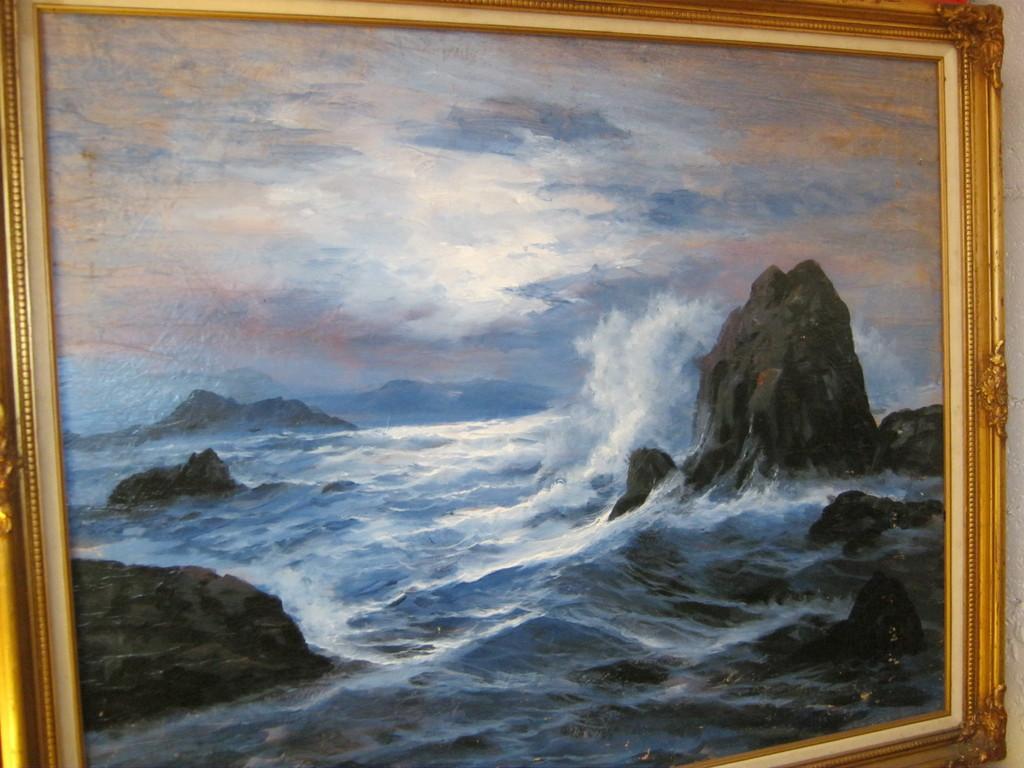Describe this image in one or two sentences. This image consists of a frame in which I can see water, rocks and sky. 